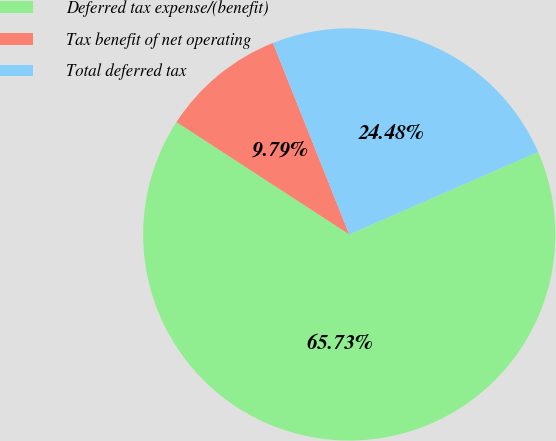Convert chart to OTSL. <chart><loc_0><loc_0><loc_500><loc_500><pie_chart><fcel>Deferred tax expense/(benefit)<fcel>Tax benefit of net operating<fcel>Total deferred tax<nl><fcel>65.73%<fcel>9.79%<fcel>24.48%<nl></chart> 